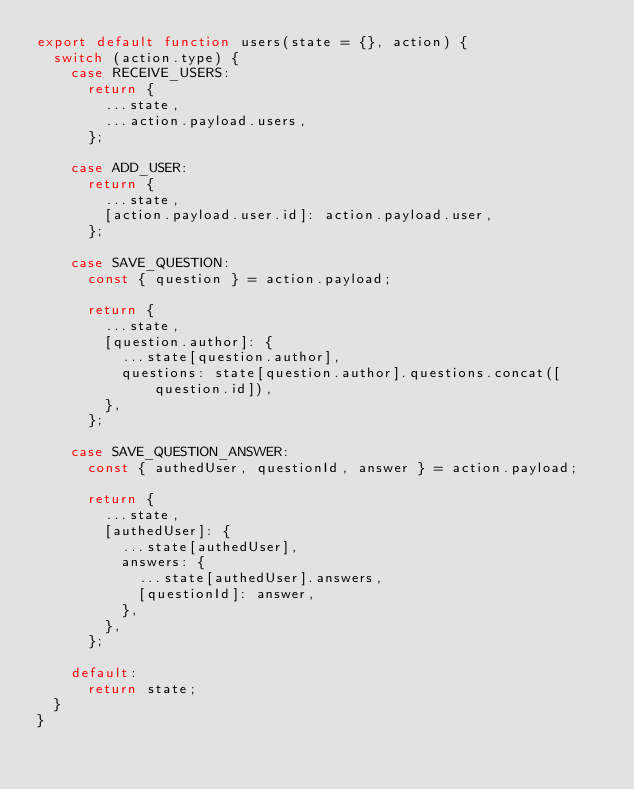Convert code to text. <code><loc_0><loc_0><loc_500><loc_500><_JavaScript_>export default function users(state = {}, action) {
  switch (action.type) {
    case RECEIVE_USERS:
      return {
        ...state,
        ...action.payload.users,
      };

    case ADD_USER:
      return {
        ...state,
        [action.payload.user.id]: action.payload.user,
      };

    case SAVE_QUESTION:
      const { question } = action.payload;

      return {
        ...state,
        [question.author]: {
          ...state[question.author],
          questions: state[question.author].questions.concat([question.id]),
        },
      };

    case SAVE_QUESTION_ANSWER:
      const { authedUser, questionId, answer } = action.payload;

      return {
        ...state,
        [authedUser]: {
          ...state[authedUser],
          answers: {
            ...state[authedUser].answers,
            [questionId]: answer,
          },
        },
      };

    default:
      return state;
  }
}
</code> 